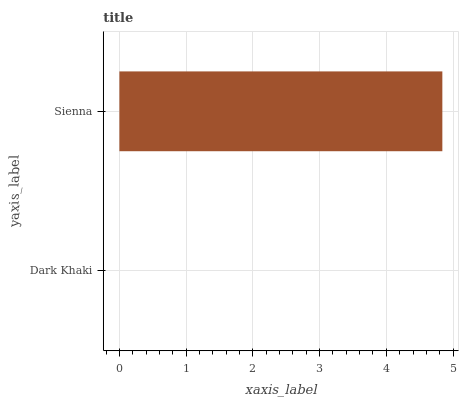Is Dark Khaki the minimum?
Answer yes or no. Yes. Is Sienna the maximum?
Answer yes or no. Yes. Is Sienna the minimum?
Answer yes or no. No. Is Sienna greater than Dark Khaki?
Answer yes or no. Yes. Is Dark Khaki less than Sienna?
Answer yes or no. Yes. Is Dark Khaki greater than Sienna?
Answer yes or no. No. Is Sienna less than Dark Khaki?
Answer yes or no. No. Is Sienna the high median?
Answer yes or no. Yes. Is Dark Khaki the low median?
Answer yes or no. Yes. Is Dark Khaki the high median?
Answer yes or no. No. Is Sienna the low median?
Answer yes or no. No. 